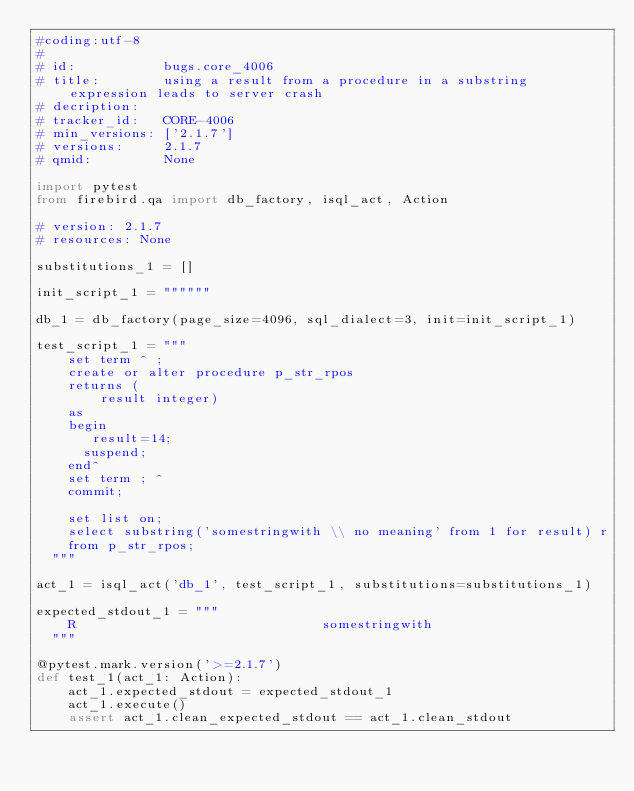Convert code to text. <code><loc_0><loc_0><loc_500><loc_500><_Python_>#coding:utf-8
#
# id:           bugs.core_4006
# title:        using a result from a procedure in a substring expression leads to server crash
# decription:   
# tracker_id:   CORE-4006
# min_versions: ['2.1.7']
# versions:     2.1.7
# qmid:         None

import pytest
from firebird.qa import db_factory, isql_act, Action

# version: 2.1.7
# resources: None

substitutions_1 = []

init_script_1 = """"""

db_1 = db_factory(page_size=4096, sql_dialect=3, init=init_script_1)

test_script_1 = """
    set term ^ ;
    create or alter procedure p_str_rpos
    returns (
        result integer)
    as
    begin
       result=14;
      suspend;
    end^
    set term ; ^
    commit;

    set list on;
    select substring('somestringwith \\ no meaning' from 1 for result) r
    from p_str_rpos; 
  """

act_1 = isql_act('db_1', test_script_1, substitutions=substitutions_1)

expected_stdout_1 = """
    R                               somestringwith
  """

@pytest.mark.version('>=2.1.7')
def test_1(act_1: Action):
    act_1.expected_stdout = expected_stdout_1
    act_1.execute()
    assert act_1.clean_expected_stdout == act_1.clean_stdout

</code> 